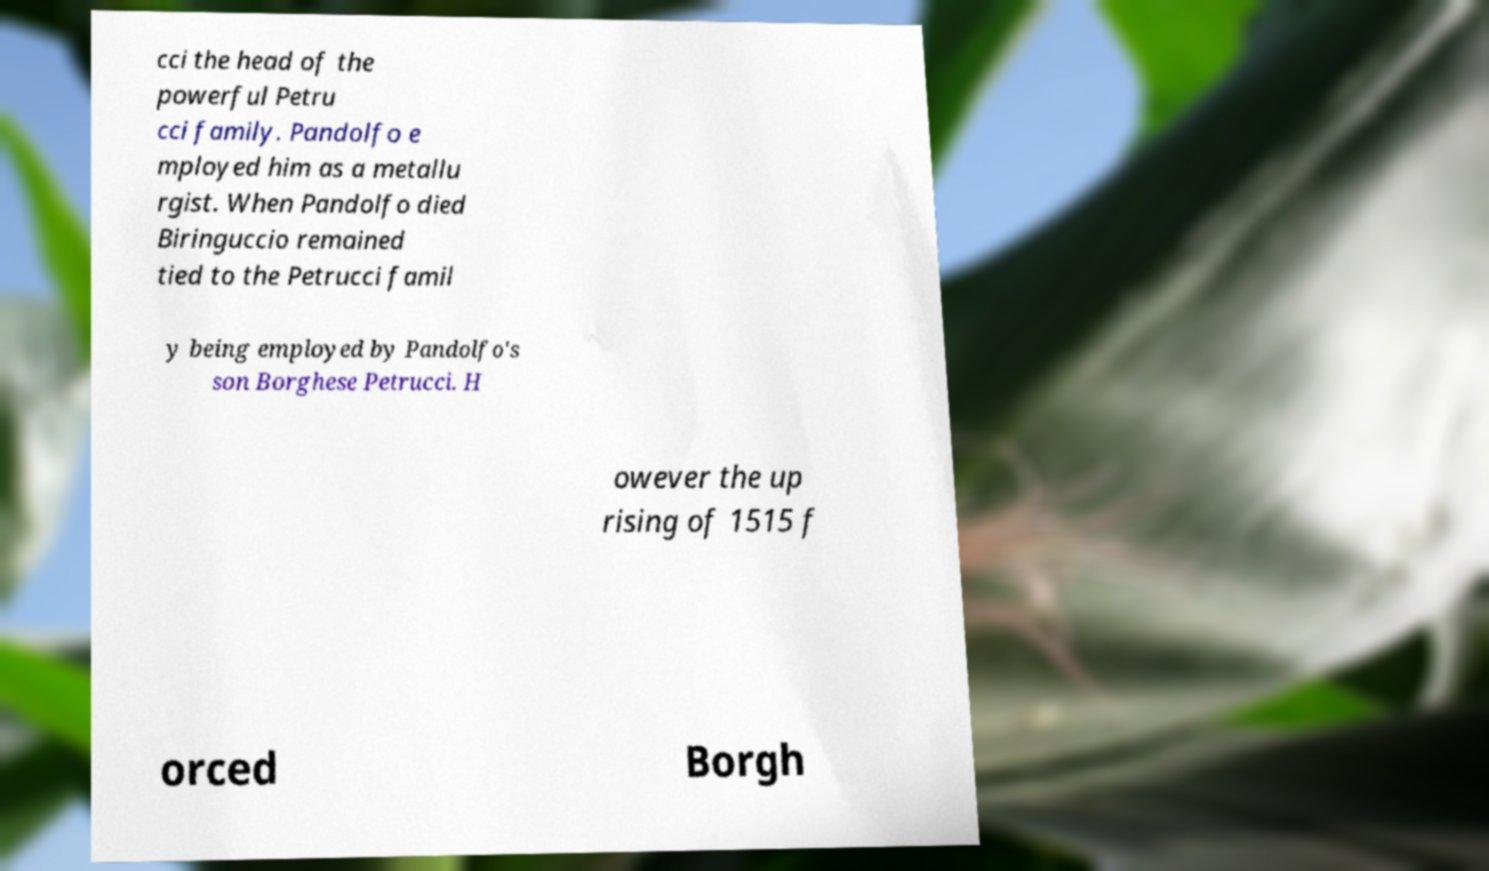Can you read and provide the text displayed in the image?This photo seems to have some interesting text. Can you extract and type it out for me? cci the head of the powerful Petru cci family. Pandolfo e mployed him as a metallu rgist. When Pandolfo died Biringuccio remained tied to the Petrucci famil y being employed by Pandolfo's son Borghese Petrucci. H owever the up rising of 1515 f orced Borgh 